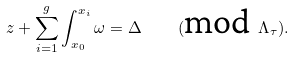<formula> <loc_0><loc_0><loc_500><loc_500>z + \sum _ { i = 1 } ^ { g } \int _ { x _ { 0 } } ^ { x _ { i } } \omega = \Delta \quad ( \text {mod} \ \Lambda _ { \tau } ) .</formula> 